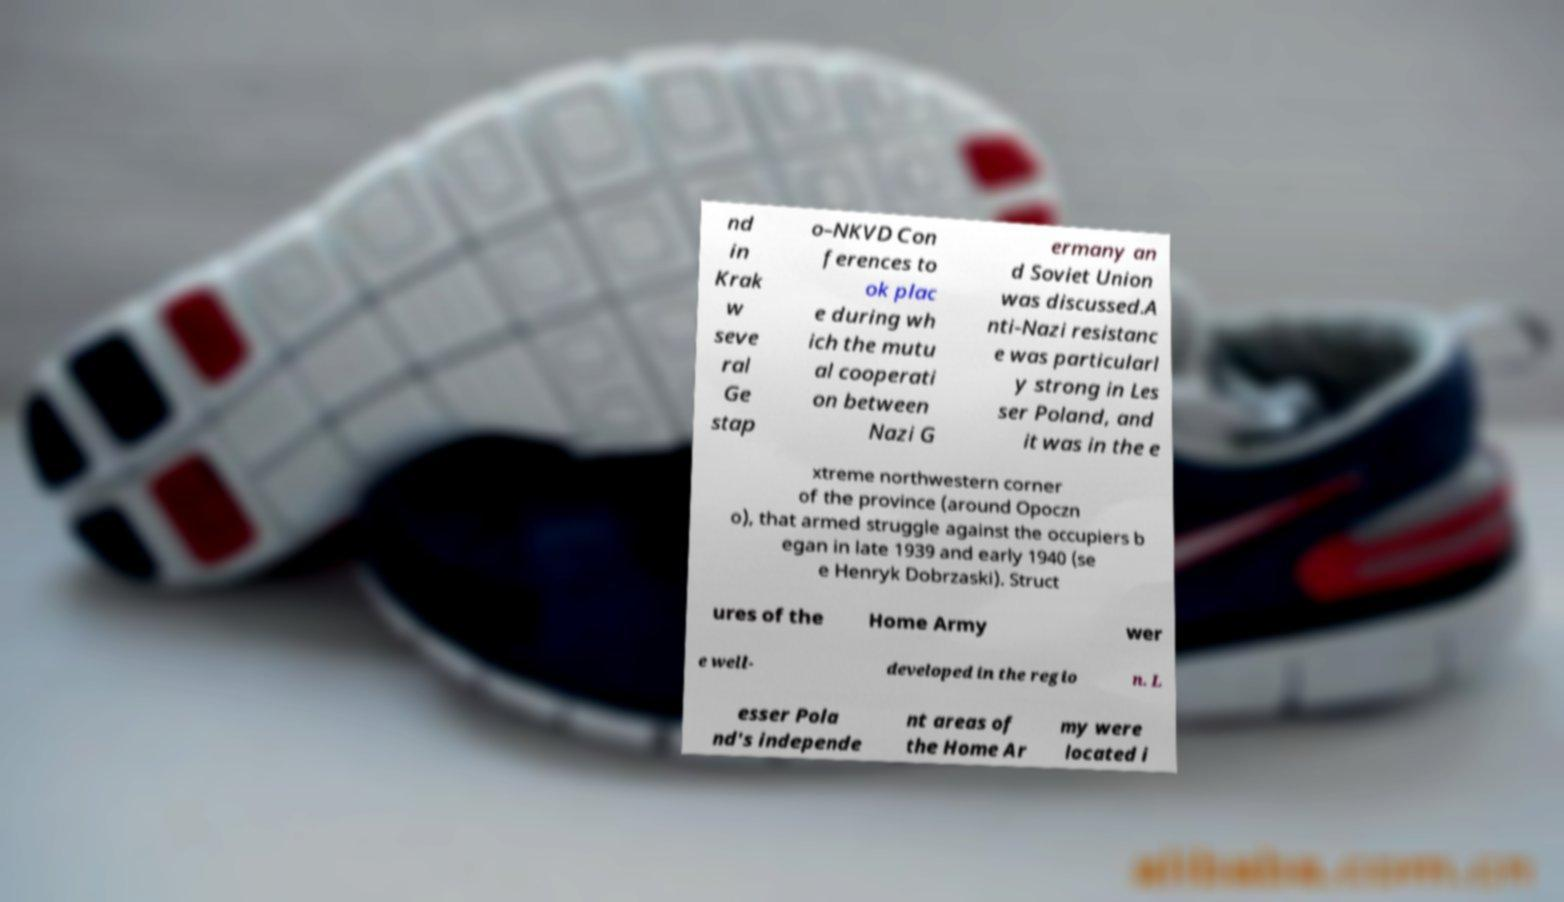Could you assist in decoding the text presented in this image and type it out clearly? nd in Krak w seve ral Ge stap o–NKVD Con ferences to ok plac e during wh ich the mutu al cooperati on between Nazi G ermany an d Soviet Union was discussed.A nti-Nazi resistanc e was particularl y strong in Les ser Poland, and it was in the e xtreme northwestern corner of the province (around Opoczn o), that armed struggle against the occupiers b egan in late 1939 and early 1940 (se e Henryk Dobrzaski). Struct ures of the Home Army wer e well- developed in the regio n. L esser Pola nd's independe nt areas of the Home Ar my were located i 